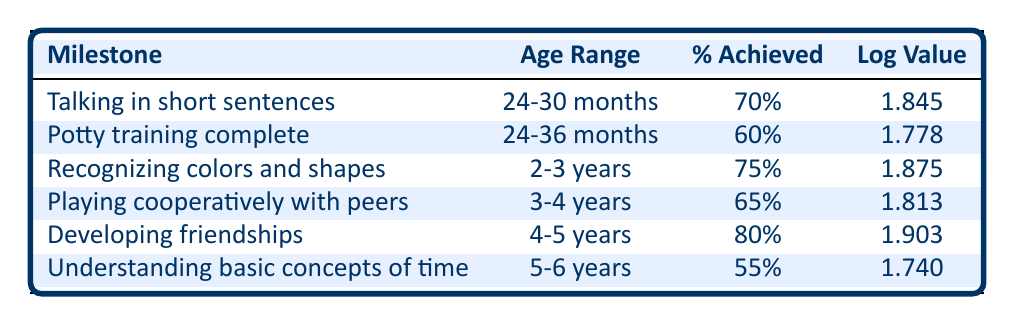What percentage of children achieve the milestone of developing friendships? The table lists the percentage for the milestone "Developing friendships" as 80%.
Answer: 80% What is the age range for recognizing colors and shapes? The age range for the milestone "Recognizing colors and shapes" is specified as 2-3 years in the table.
Answer: 2-3 years Which milestone has the highest percentage achieved? Upon reviewing the percentages in the table, "Developing friendships" has the highest percentage at 80%, compared to others like "Talking in short sentences" at 70% and "Understanding basic concepts of time" at 55%.
Answer: Developing friendships What is the average percentage achieved across all milestones? To calculate the average, sum all the percentages: (70 + 60 + 75 + 65 + 80 + 55) = 405. Divide by the number of milestones (6): 405 / 6 = 67.5.
Answer: 67.5 Is the percentage achieved for understanding basic concepts of time greater than 50%? The table shows that the percentage achieved for the milestone "Understanding basic concepts of time" is 55%, which is indeed greater than 50%.
Answer: Yes What is the difference in percentage achieved between talking in short sentences and playing cooperatively with peers? The percentage for "Talking in short sentences" is 70% and for "Playing cooperatively with peers," it is 65%. The difference is 70 - 65 = 5%.
Answer: 5% How many milestones have a percentage achieved below 70%? The percentages below 70% are for "Potty training complete" (60%), "Playing cooperatively with peers" (65%), and "Understanding basic concepts of time" (55%). Therefore, there are three milestones with percentages below 70%.
Answer: 3 What is the log value for potty training complete? The log value associated with the milestone "Potty training complete" is stated as 1.778 in the table.
Answer: 1.778 Do more children achieve recognizing colors and shapes than potty training complete? The percentage of children achieving "Recognizing colors and shapes" is 75%, while for "Potty training complete" it is 60%. Since 75% is greater than 60%, the answer is yes.
Answer: Yes 